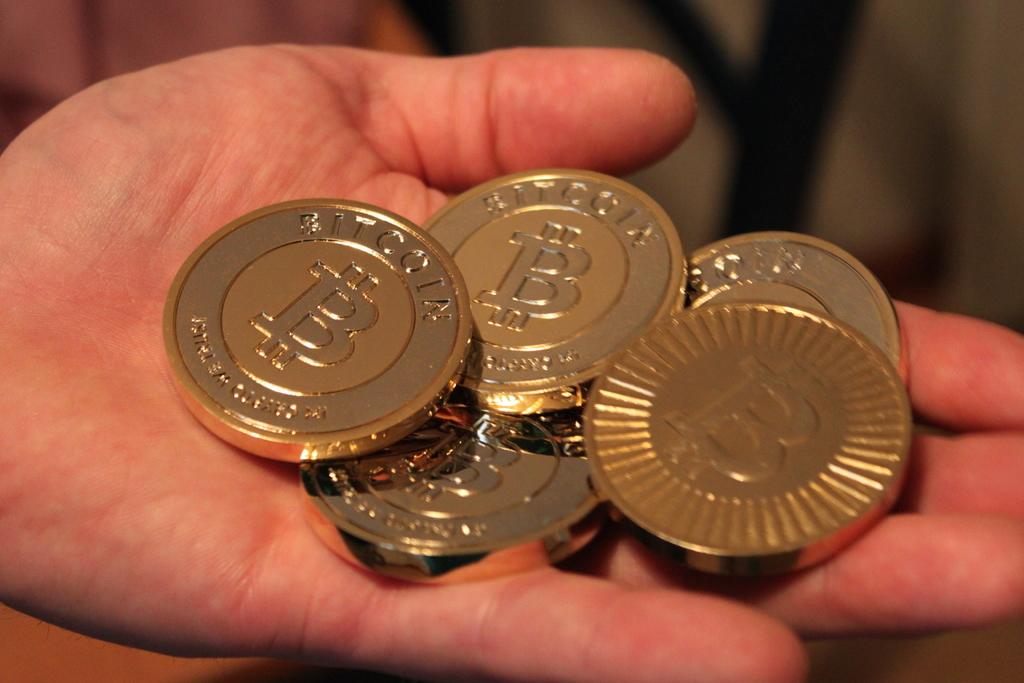<image>
Write a terse but informative summary of the picture. Five gold bitcoins with the letter B on them rest in someones hand. 